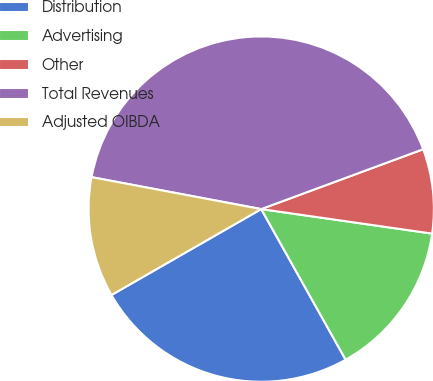Convert chart. <chart><loc_0><loc_0><loc_500><loc_500><pie_chart><fcel>Distribution<fcel>Advertising<fcel>Other<fcel>Total Revenues<fcel>Adjusted OIBDA<nl><fcel>24.84%<fcel>14.6%<fcel>7.9%<fcel>41.4%<fcel>11.25%<nl></chart> 